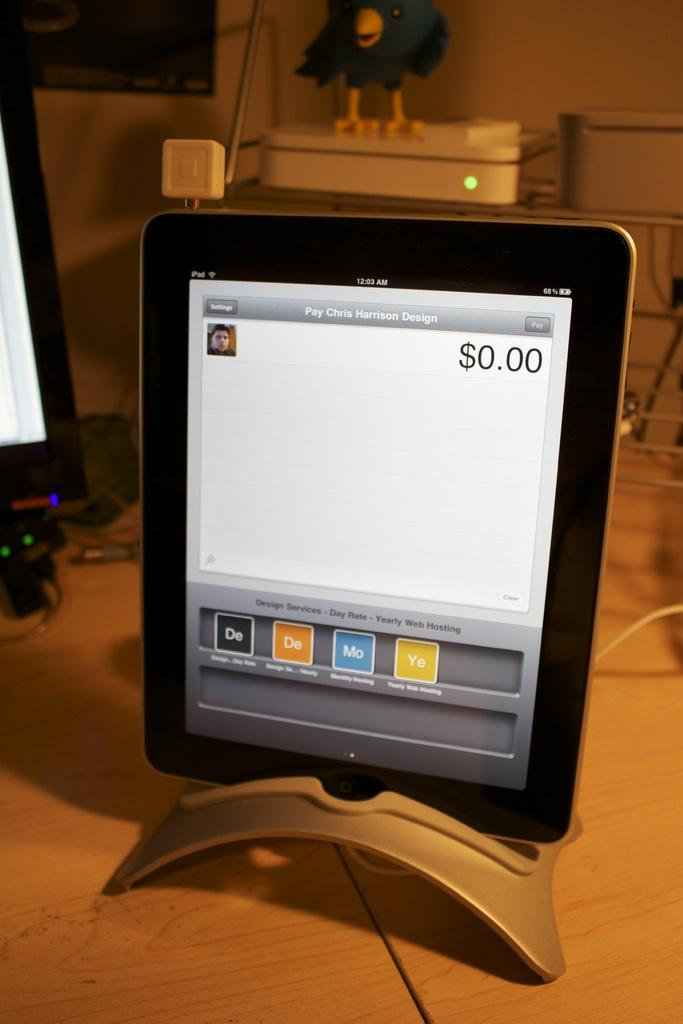<image>
Present a compact description of the photo's key features. A tablet reads Pay Chris Harrison Design and shows the balance as $0.00. 